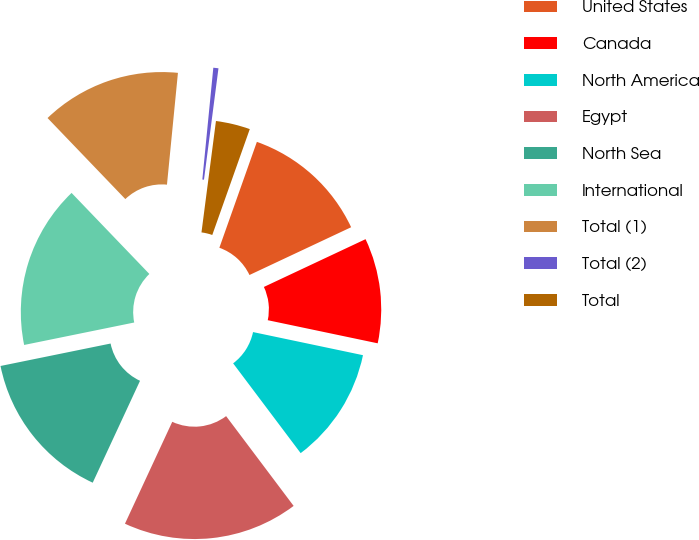<chart> <loc_0><loc_0><loc_500><loc_500><pie_chart><fcel>United States<fcel>Canada<fcel>North America<fcel>Egypt<fcel>North Sea<fcel>International<fcel>Total (1)<fcel>Total (2)<fcel>Total<nl><fcel>12.59%<fcel>10.29%<fcel>11.44%<fcel>17.18%<fcel>14.88%<fcel>16.03%<fcel>13.73%<fcel>0.5%<fcel>3.36%<nl></chart> 